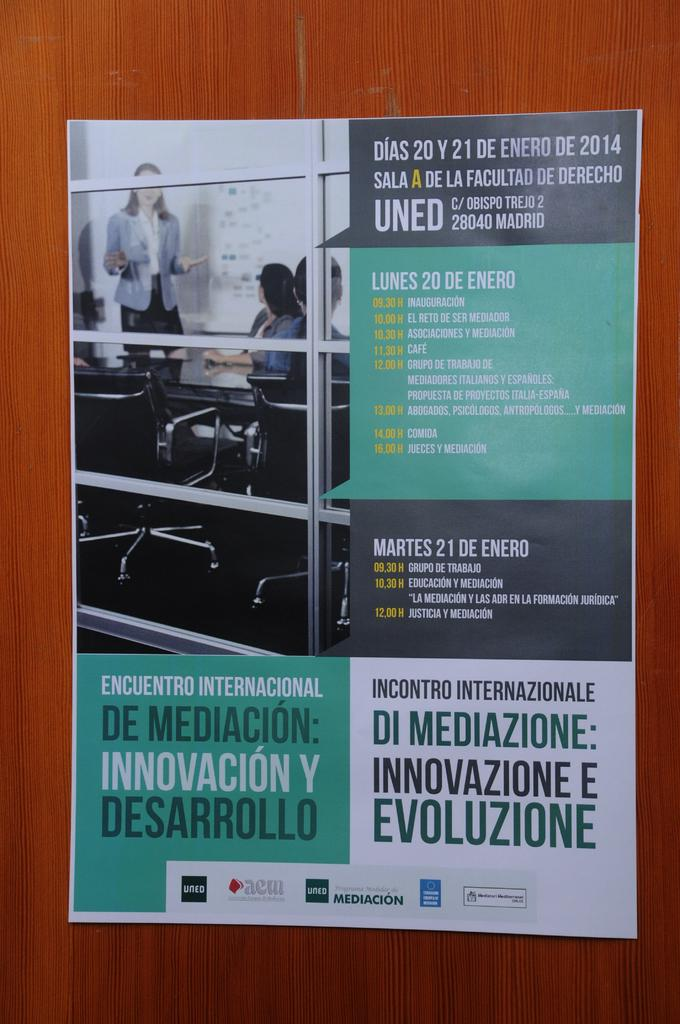What type of furniture is present in the image? There is a table in the image. What is hanging on the wall in the image? There is a poster in the image. What can be seen on the poster? The poster has an image. What else is featured on the poster besides the image? The poster has text. Is there a liquid spilled on the desk in the image? There is no desk present in the image, and therefore no liquid can be spilled on it. What type of degree is mentioned on the poster in the image? There is no mention of a degree on the poster in the image. 